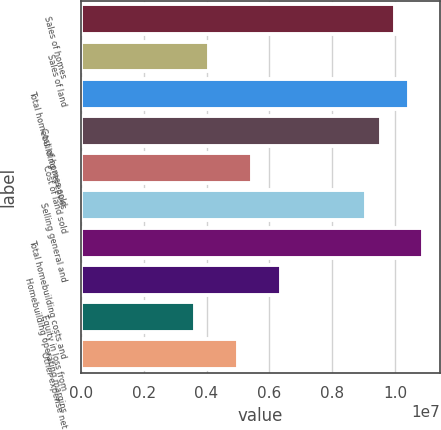Convert chart. <chart><loc_0><loc_0><loc_500><loc_500><bar_chart><fcel>Sales of homes<fcel>Sales of land<fcel>Total homebuilding revenues<fcel>Cost of homes sold<fcel>Cost of land sold<fcel>Selling general and<fcel>Total homebuilding costs and<fcel>Homebuilding operating margins<fcel>Equity in loss from<fcel>Other expense net<nl><fcel>9.99214e+06<fcel>4.08769e+06<fcel>1.04463e+07<fcel>9.53795e+06<fcel>5.45026e+06<fcel>9.08376e+06<fcel>1.09005e+07<fcel>6.35863e+06<fcel>3.63351e+06<fcel>4.99607e+06<nl></chart> 